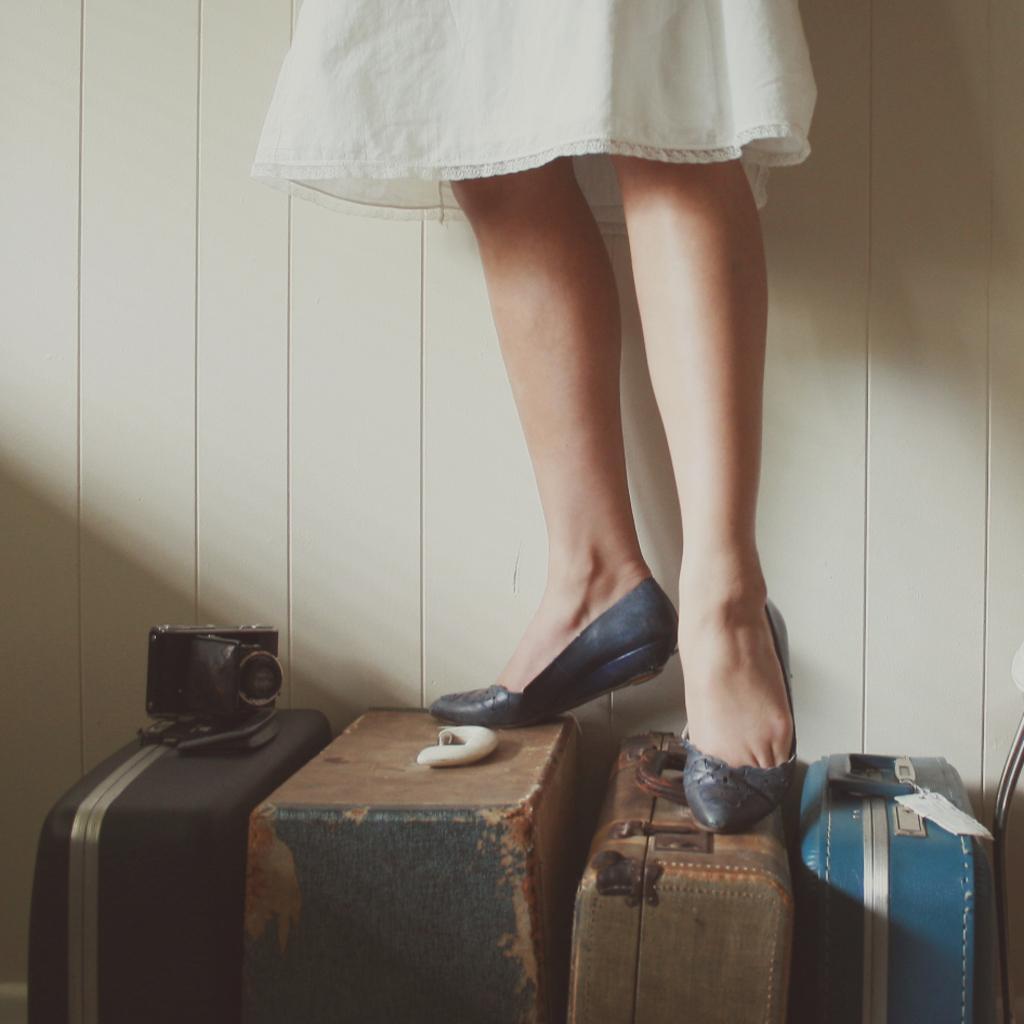Can you describe this image briefly? In this picture we can see a woman standing on suitcase. This is a device on the suitcase. 